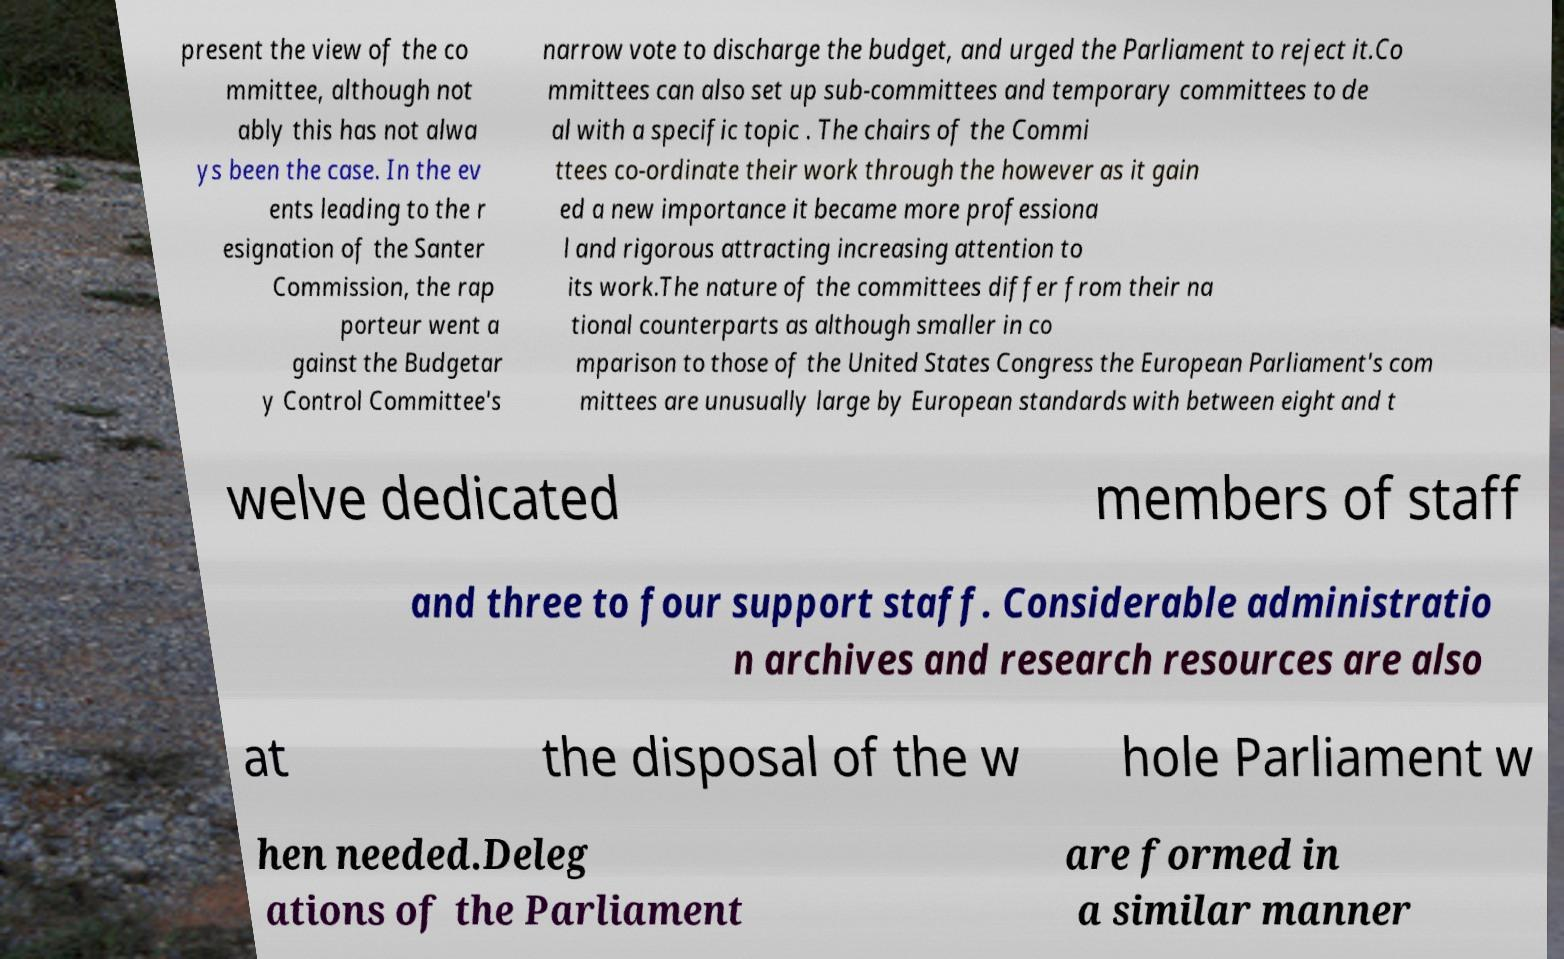Please identify and transcribe the text found in this image. present the view of the co mmittee, although not ably this has not alwa ys been the case. In the ev ents leading to the r esignation of the Santer Commission, the rap porteur went a gainst the Budgetar y Control Committee's narrow vote to discharge the budget, and urged the Parliament to reject it.Co mmittees can also set up sub-committees and temporary committees to de al with a specific topic . The chairs of the Commi ttees co-ordinate their work through the however as it gain ed a new importance it became more professiona l and rigorous attracting increasing attention to its work.The nature of the committees differ from their na tional counterparts as although smaller in co mparison to those of the United States Congress the European Parliament's com mittees are unusually large by European standards with between eight and t welve dedicated members of staff and three to four support staff. Considerable administratio n archives and research resources are also at the disposal of the w hole Parliament w hen needed.Deleg ations of the Parliament are formed in a similar manner 